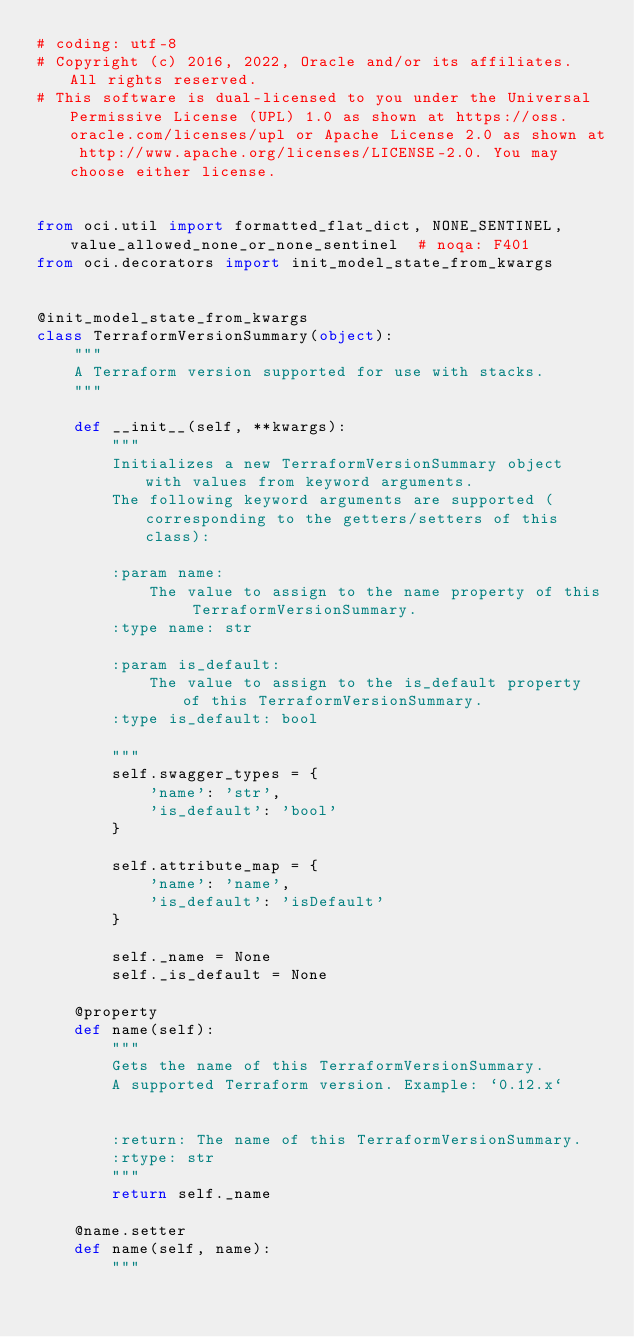<code> <loc_0><loc_0><loc_500><loc_500><_Python_># coding: utf-8
# Copyright (c) 2016, 2022, Oracle and/or its affiliates.  All rights reserved.
# This software is dual-licensed to you under the Universal Permissive License (UPL) 1.0 as shown at https://oss.oracle.com/licenses/upl or Apache License 2.0 as shown at http://www.apache.org/licenses/LICENSE-2.0. You may choose either license.


from oci.util import formatted_flat_dict, NONE_SENTINEL, value_allowed_none_or_none_sentinel  # noqa: F401
from oci.decorators import init_model_state_from_kwargs


@init_model_state_from_kwargs
class TerraformVersionSummary(object):
    """
    A Terraform version supported for use with stacks.
    """

    def __init__(self, **kwargs):
        """
        Initializes a new TerraformVersionSummary object with values from keyword arguments.
        The following keyword arguments are supported (corresponding to the getters/setters of this class):

        :param name:
            The value to assign to the name property of this TerraformVersionSummary.
        :type name: str

        :param is_default:
            The value to assign to the is_default property of this TerraformVersionSummary.
        :type is_default: bool

        """
        self.swagger_types = {
            'name': 'str',
            'is_default': 'bool'
        }

        self.attribute_map = {
            'name': 'name',
            'is_default': 'isDefault'
        }

        self._name = None
        self._is_default = None

    @property
    def name(self):
        """
        Gets the name of this TerraformVersionSummary.
        A supported Terraform version. Example: `0.12.x`


        :return: The name of this TerraformVersionSummary.
        :rtype: str
        """
        return self._name

    @name.setter
    def name(self, name):
        """</code> 